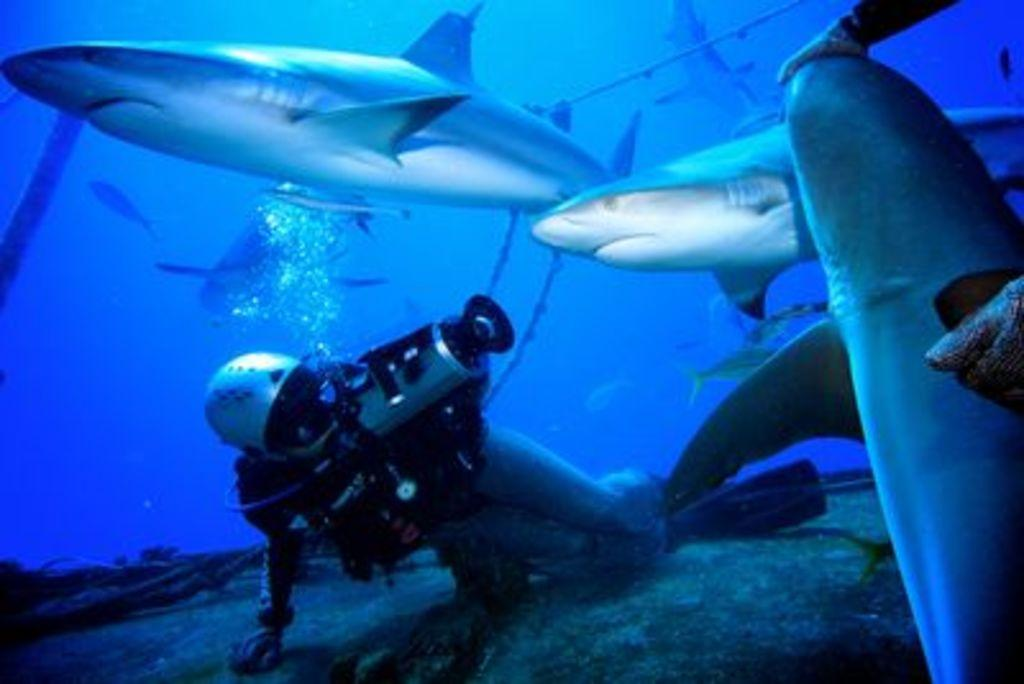What is the person in the image doing? The person is doing scuba diving. Where is the person located in the image? The person is underwater. What can be seen around the person in the image? There are many fishes around the person. What type of event is the fireman attending in the image? There is no fireman or event present in the image; it features a person doing scuba diving underwater with many fishes around. Can you tell me how many gravestones are visible in the image? There are no gravestones or cemeteries present in the image; it features a person doing scuba diving underwater with many fishes around. 